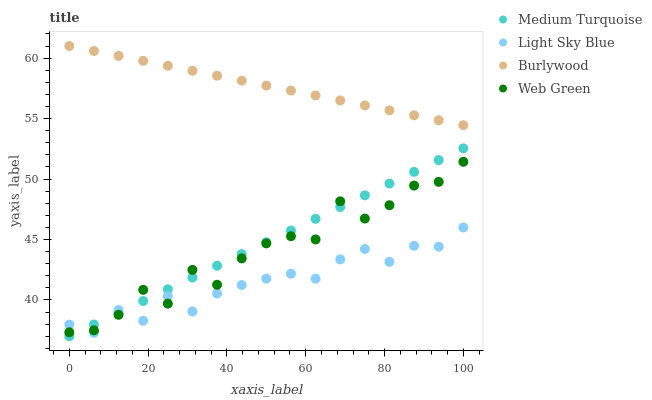Does Light Sky Blue have the minimum area under the curve?
Answer yes or no. Yes. Does Burlywood have the maximum area under the curve?
Answer yes or no. Yes. Does Web Green have the minimum area under the curve?
Answer yes or no. No. Does Web Green have the maximum area under the curve?
Answer yes or no. No. Is Burlywood the smoothest?
Answer yes or no. Yes. Is Web Green the roughest?
Answer yes or no. Yes. Is Light Sky Blue the smoothest?
Answer yes or no. No. Is Light Sky Blue the roughest?
Answer yes or no. No. Does Medium Turquoise have the lowest value?
Answer yes or no. Yes. Does Light Sky Blue have the lowest value?
Answer yes or no. No. Does Burlywood have the highest value?
Answer yes or no. Yes. Does Web Green have the highest value?
Answer yes or no. No. Is Web Green less than Burlywood?
Answer yes or no. Yes. Is Burlywood greater than Medium Turquoise?
Answer yes or no. Yes. Does Web Green intersect Medium Turquoise?
Answer yes or no. Yes. Is Web Green less than Medium Turquoise?
Answer yes or no. No. Is Web Green greater than Medium Turquoise?
Answer yes or no. No. Does Web Green intersect Burlywood?
Answer yes or no. No. 